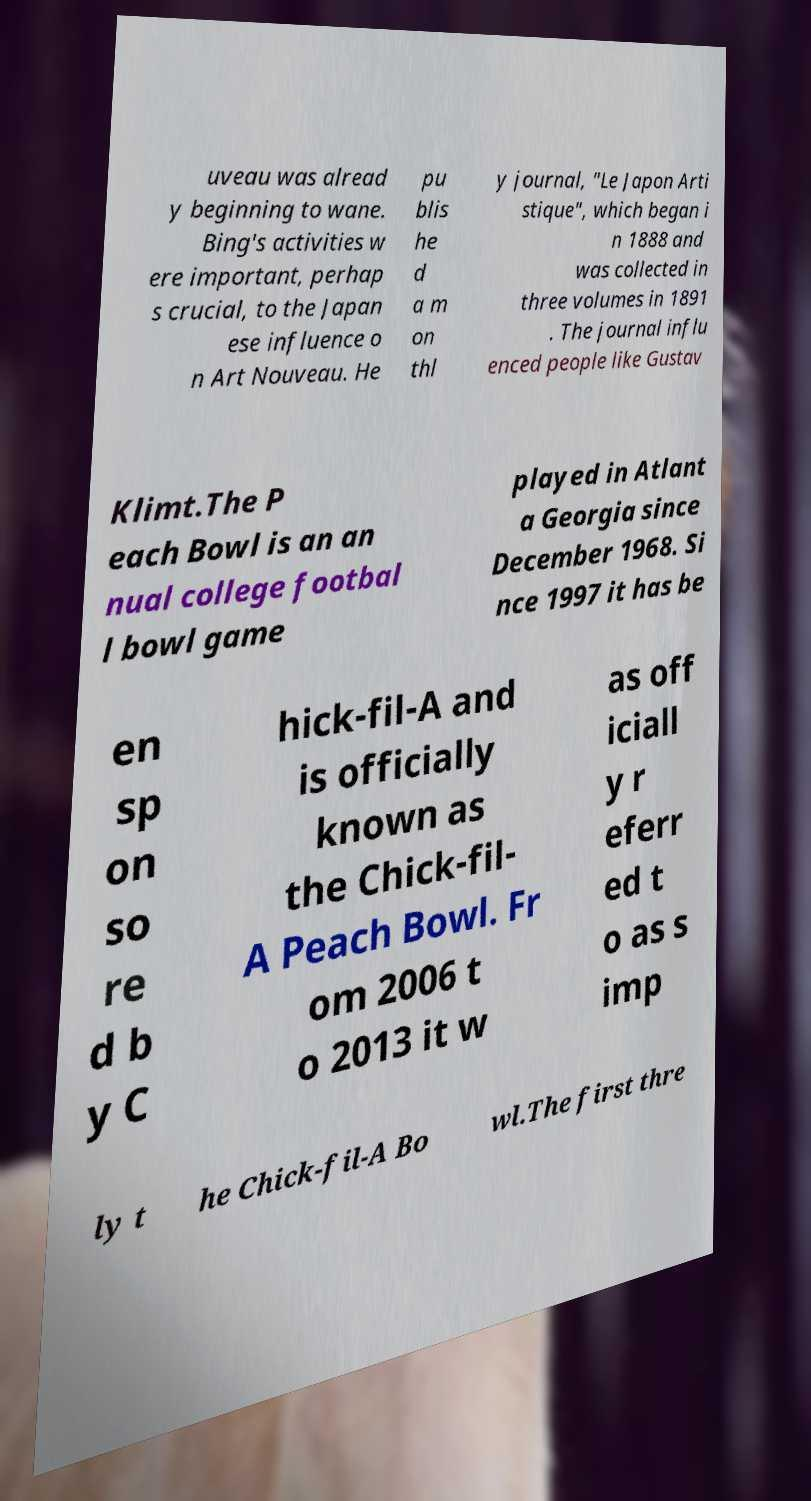Could you assist in decoding the text presented in this image and type it out clearly? uveau was alread y beginning to wane. Bing's activities w ere important, perhap s crucial, to the Japan ese influence o n Art Nouveau. He pu blis he d a m on thl y journal, "Le Japon Arti stique", which began i n 1888 and was collected in three volumes in 1891 . The journal influ enced people like Gustav Klimt.The P each Bowl is an an nual college footbal l bowl game played in Atlant a Georgia since December 1968. Si nce 1997 it has be en sp on so re d b y C hick-fil-A and is officially known as the Chick-fil- A Peach Bowl. Fr om 2006 t o 2013 it w as off iciall y r eferr ed t o as s imp ly t he Chick-fil-A Bo wl.The first thre 